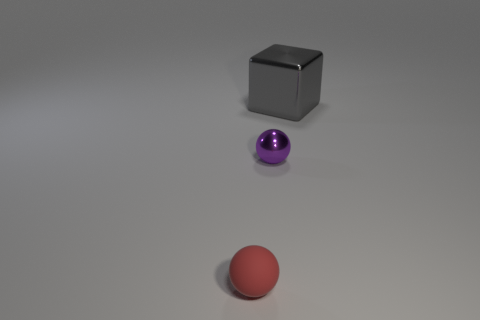Are there any other things that have the same size as the gray metal object?
Your answer should be compact. No. Is the number of cyan cylinders greater than the number of small purple metallic things?
Make the answer very short. No. There is a object behind the ball that is behind the small matte object; what is its size?
Give a very brief answer. Large. There is another metallic thing that is the same shape as the red object; what color is it?
Provide a short and direct response. Purple. How big is the cube?
Keep it short and to the point. Large. How many cylinders are small red objects or large metal things?
Keep it short and to the point. 0. What number of tiny gray rubber balls are there?
Ensure brevity in your answer.  0. Is the shape of the red matte thing the same as the metal object behind the purple ball?
Provide a short and direct response. No. There is a ball in front of the purple metal thing; what size is it?
Offer a very short reply. Small. What is the material of the purple object?
Your answer should be very brief. Metal. 